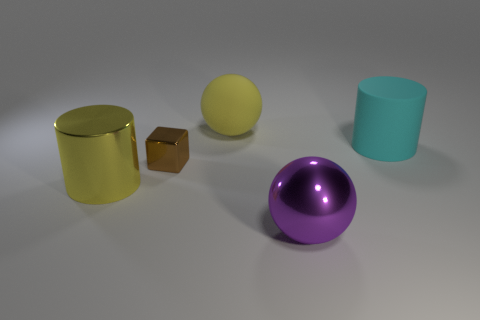Add 1 small brown shiny cylinders. How many objects exist? 6 Subtract all blocks. How many objects are left? 4 Add 1 big yellow metal objects. How many big yellow metal objects are left? 2 Add 4 tiny brown shiny objects. How many tiny brown shiny objects exist? 5 Subtract 1 yellow spheres. How many objects are left? 4 Subtract all metallic blocks. Subtract all small brown metallic objects. How many objects are left? 3 